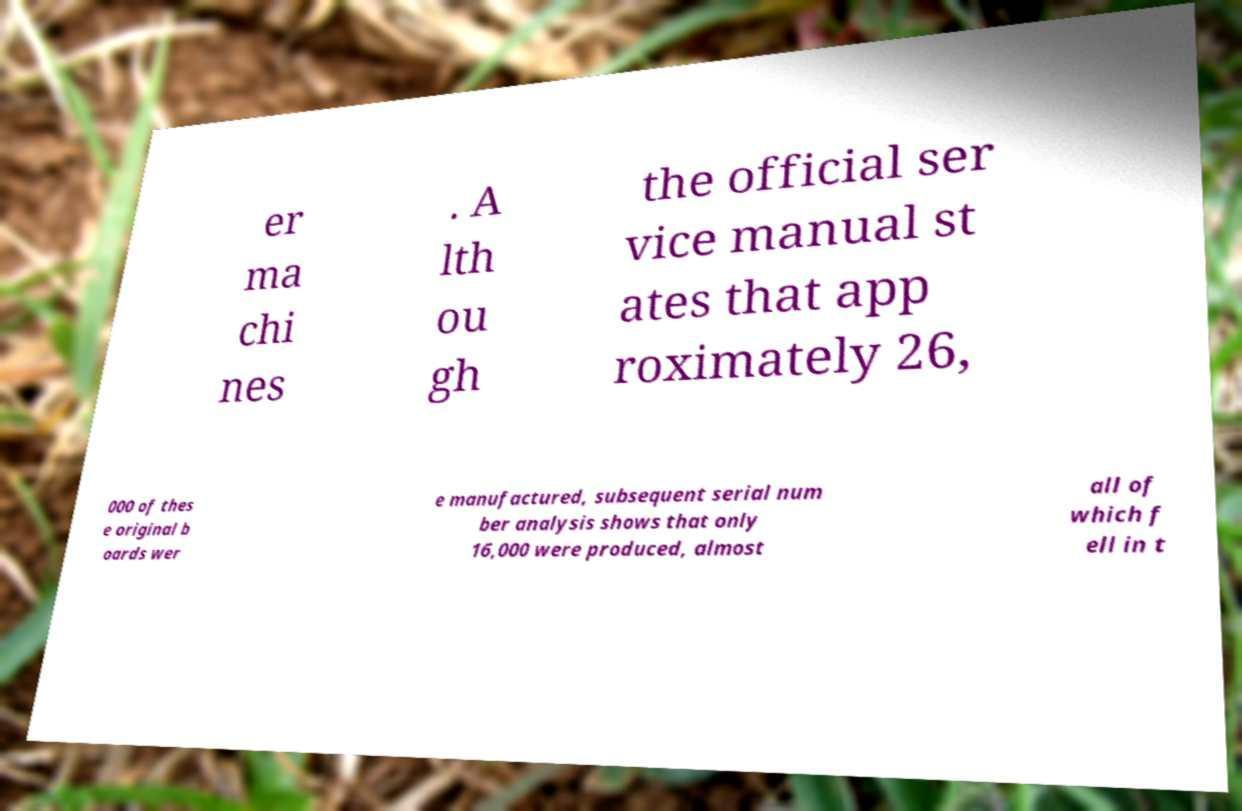For documentation purposes, I need the text within this image transcribed. Could you provide that? er ma chi nes . A lth ou gh the official ser vice manual st ates that app roximately 26, 000 of thes e original b oards wer e manufactured, subsequent serial num ber analysis shows that only 16,000 were produced, almost all of which f ell in t 